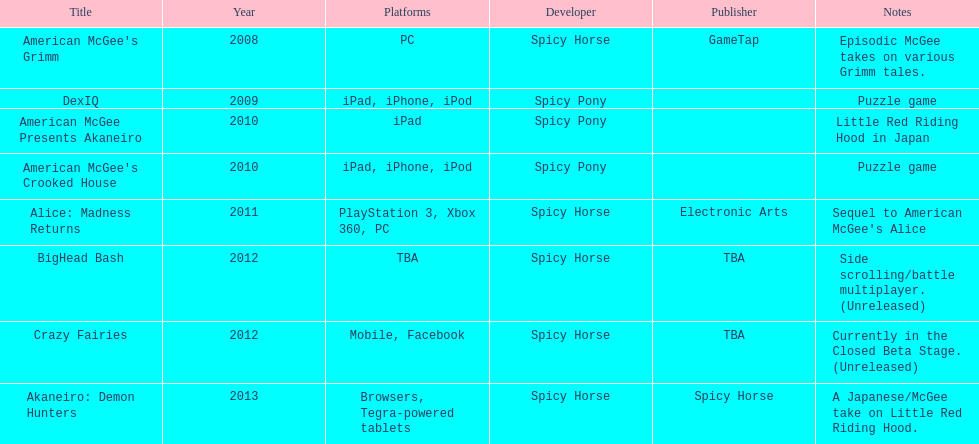What was the last game created by spicy horse Akaneiro: Demon Hunters. 